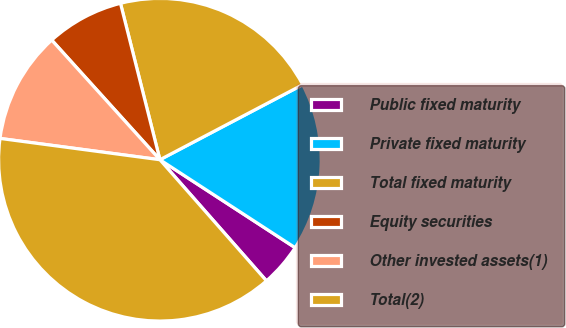Convert chart. <chart><loc_0><loc_0><loc_500><loc_500><pie_chart><fcel>Public fixed maturity<fcel>Private fixed maturity<fcel>Total fixed maturity<fcel>Equity securities<fcel>Other invested assets(1)<fcel>Total(2)<nl><fcel>4.34%<fcel>16.88%<fcel>21.23%<fcel>7.77%<fcel>11.19%<fcel>38.59%<nl></chart> 